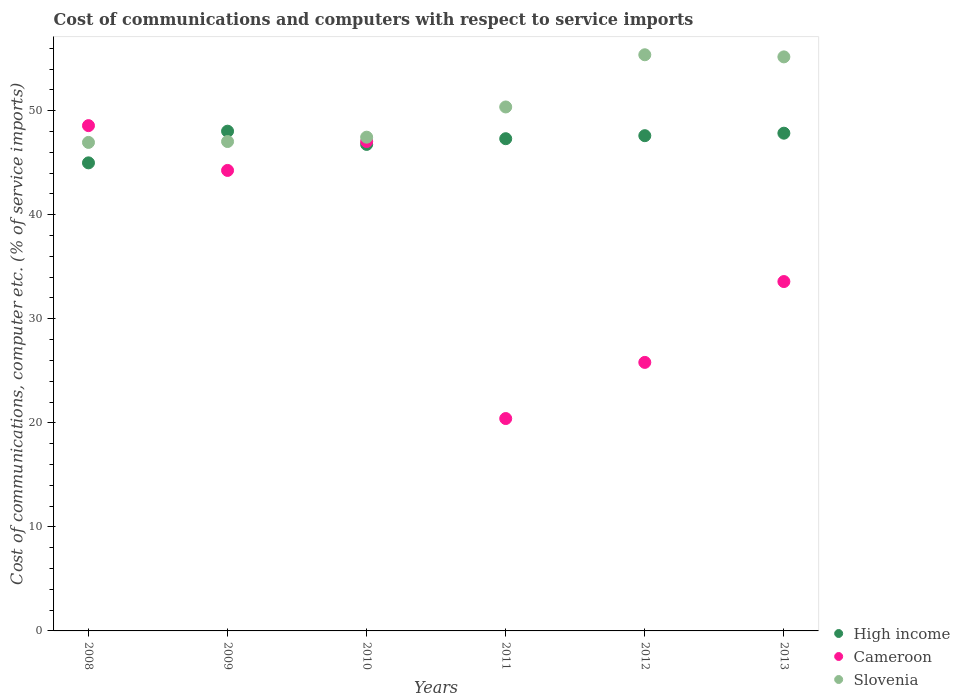What is the cost of communications and computers in Slovenia in 2009?
Make the answer very short. 47.03. Across all years, what is the maximum cost of communications and computers in Cameroon?
Ensure brevity in your answer.  48.56. Across all years, what is the minimum cost of communications and computers in Slovenia?
Provide a short and direct response. 46.95. In which year was the cost of communications and computers in High income maximum?
Offer a very short reply. 2009. What is the total cost of communications and computers in Cameroon in the graph?
Your answer should be compact. 219.64. What is the difference between the cost of communications and computers in Slovenia in 2009 and that in 2011?
Provide a short and direct response. -3.32. What is the difference between the cost of communications and computers in High income in 2008 and the cost of communications and computers in Slovenia in 2009?
Keep it short and to the point. -2.05. What is the average cost of communications and computers in Cameroon per year?
Your response must be concise. 36.61. In the year 2009, what is the difference between the cost of communications and computers in Slovenia and cost of communications and computers in High income?
Keep it short and to the point. -0.99. In how many years, is the cost of communications and computers in Slovenia greater than 16 %?
Offer a terse response. 6. What is the ratio of the cost of communications and computers in High income in 2008 to that in 2010?
Give a very brief answer. 0.96. Is the cost of communications and computers in High income in 2008 less than that in 2012?
Your response must be concise. Yes. What is the difference between the highest and the second highest cost of communications and computers in High income?
Offer a very short reply. 0.19. What is the difference between the highest and the lowest cost of communications and computers in Cameroon?
Ensure brevity in your answer.  28.15. Is it the case that in every year, the sum of the cost of communications and computers in Slovenia and cost of communications and computers in High income  is greater than the cost of communications and computers in Cameroon?
Give a very brief answer. Yes. Does the cost of communications and computers in Cameroon monotonically increase over the years?
Offer a terse response. No. Is the cost of communications and computers in High income strictly greater than the cost of communications and computers in Cameroon over the years?
Offer a terse response. No. Is the cost of communications and computers in Slovenia strictly less than the cost of communications and computers in Cameroon over the years?
Your answer should be compact. No. How many years are there in the graph?
Your answer should be compact. 6. Are the values on the major ticks of Y-axis written in scientific E-notation?
Give a very brief answer. No. Does the graph contain grids?
Provide a succinct answer. No. How many legend labels are there?
Your answer should be compact. 3. What is the title of the graph?
Provide a succinct answer. Cost of communications and computers with respect to service imports. What is the label or title of the X-axis?
Offer a terse response. Years. What is the label or title of the Y-axis?
Offer a terse response. Cost of communications, computer etc. (% of service imports). What is the Cost of communications, computer etc. (% of service imports) of High income in 2008?
Make the answer very short. 44.98. What is the Cost of communications, computer etc. (% of service imports) in Cameroon in 2008?
Ensure brevity in your answer.  48.56. What is the Cost of communications, computer etc. (% of service imports) in Slovenia in 2008?
Your response must be concise. 46.95. What is the Cost of communications, computer etc. (% of service imports) of High income in 2009?
Your answer should be compact. 48.03. What is the Cost of communications, computer etc. (% of service imports) of Cameroon in 2009?
Keep it short and to the point. 44.26. What is the Cost of communications, computer etc. (% of service imports) of Slovenia in 2009?
Your answer should be very brief. 47.03. What is the Cost of communications, computer etc. (% of service imports) of High income in 2010?
Provide a short and direct response. 46.76. What is the Cost of communications, computer etc. (% of service imports) in Cameroon in 2010?
Give a very brief answer. 47.03. What is the Cost of communications, computer etc. (% of service imports) of Slovenia in 2010?
Offer a terse response. 47.45. What is the Cost of communications, computer etc. (% of service imports) in High income in 2011?
Keep it short and to the point. 47.3. What is the Cost of communications, computer etc. (% of service imports) in Cameroon in 2011?
Provide a short and direct response. 20.41. What is the Cost of communications, computer etc. (% of service imports) of Slovenia in 2011?
Your answer should be compact. 50.35. What is the Cost of communications, computer etc. (% of service imports) of High income in 2012?
Provide a succinct answer. 47.59. What is the Cost of communications, computer etc. (% of service imports) in Cameroon in 2012?
Ensure brevity in your answer.  25.81. What is the Cost of communications, computer etc. (% of service imports) of Slovenia in 2012?
Provide a short and direct response. 55.37. What is the Cost of communications, computer etc. (% of service imports) of High income in 2013?
Your answer should be compact. 47.83. What is the Cost of communications, computer etc. (% of service imports) of Cameroon in 2013?
Ensure brevity in your answer.  33.58. What is the Cost of communications, computer etc. (% of service imports) of Slovenia in 2013?
Your answer should be compact. 55.17. Across all years, what is the maximum Cost of communications, computer etc. (% of service imports) in High income?
Ensure brevity in your answer.  48.03. Across all years, what is the maximum Cost of communications, computer etc. (% of service imports) of Cameroon?
Provide a succinct answer. 48.56. Across all years, what is the maximum Cost of communications, computer etc. (% of service imports) in Slovenia?
Keep it short and to the point. 55.37. Across all years, what is the minimum Cost of communications, computer etc. (% of service imports) in High income?
Provide a short and direct response. 44.98. Across all years, what is the minimum Cost of communications, computer etc. (% of service imports) in Cameroon?
Provide a short and direct response. 20.41. Across all years, what is the minimum Cost of communications, computer etc. (% of service imports) in Slovenia?
Provide a succinct answer. 46.95. What is the total Cost of communications, computer etc. (% of service imports) in High income in the graph?
Provide a short and direct response. 282.5. What is the total Cost of communications, computer etc. (% of service imports) of Cameroon in the graph?
Give a very brief answer. 219.64. What is the total Cost of communications, computer etc. (% of service imports) of Slovenia in the graph?
Provide a short and direct response. 302.32. What is the difference between the Cost of communications, computer etc. (% of service imports) in High income in 2008 and that in 2009?
Provide a succinct answer. -3.04. What is the difference between the Cost of communications, computer etc. (% of service imports) in Cameroon in 2008 and that in 2009?
Offer a very short reply. 4.3. What is the difference between the Cost of communications, computer etc. (% of service imports) in Slovenia in 2008 and that in 2009?
Ensure brevity in your answer.  -0.08. What is the difference between the Cost of communications, computer etc. (% of service imports) in High income in 2008 and that in 2010?
Provide a succinct answer. -1.77. What is the difference between the Cost of communications, computer etc. (% of service imports) of Cameroon in 2008 and that in 2010?
Your response must be concise. 1.53. What is the difference between the Cost of communications, computer etc. (% of service imports) of Slovenia in 2008 and that in 2010?
Ensure brevity in your answer.  -0.5. What is the difference between the Cost of communications, computer etc. (% of service imports) in High income in 2008 and that in 2011?
Provide a succinct answer. -2.32. What is the difference between the Cost of communications, computer etc. (% of service imports) of Cameroon in 2008 and that in 2011?
Offer a terse response. 28.15. What is the difference between the Cost of communications, computer etc. (% of service imports) in Slovenia in 2008 and that in 2011?
Offer a terse response. -3.41. What is the difference between the Cost of communications, computer etc. (% of service imports) in High income in 2008 and that in 2012?
Give a very brief answer. -2.61. What is the difference between the Cost of communications, computer etc. (% of service imports) in Cameroon in 2008 and that in 2012?
Make the answer very short. 22.75. What is the difference between the Cost of communications, computer etc. (% of service imports) of Slovenia in 2008 and that in 2012?
Your answer should be very brief. -8.42. What is the difference between the Cost of communications, computer etc. (% of service imports) in High income in 2008 and that in 2013?
Your response must be concise. -2.85. What is the difference between the Cost of communications, computer etc. (% of service imports) of Cameroon in 2008 and that in 2013?
Ensure brevity in your answer.  14.98. What is the difference between the Cost of communications, computer etc. (% of service imports) of Slovenia in 2008 and that in 2013?
Your answer should be very brief. -8.22. What is the difference between the Cost of communications, computer etc. (% of service imports) of High income in 2009 and that in 2010?
Your answer should be compact. 1.27. What is the difference between the Cost of communications, computer etc. (% of service imports) in Cameroon in 2009 and that in 2010?
Your answer should be very brief. -2.78. What is the difference between the Cost of communications, computer etc. (% of service imports) in Slovenia in 2009 and that in 2010?
Make the answer very short. -0.42. What is the difference between the Cost of communications, computer etc. (% of service imports) of High income in 2009 and that in 2011?
Offer a terse response. 0.72. What is the difference between the Cost of communications, computer etc. (% of service imports) of Cameroon in 2009 and that in 2011?
Offer a terse response. 23.85. What is the difference between the Cost of communications, computer etc. (% of service imports) in Slovenia in 2009 and that in 2011?
Give a very brief answer. -3.32. What is the difference between the Cost of communications, computer etc. (% of service imports) in High income in 2009 and that in 2012?
Keep it short and to the point. 0.43. What is the difference between the Cost of communications, computer etc. (% of service imports) of Cameroon in 2009 and that in 2012?
Your response must be concise. 18.45. What is the difference between the Cost of communications, computer etc. (% of service imports) in Slovenia in 2009 and that in 2012?
Your answer should be compact. -8.34. What is the difference between the Cost of communications, computer etc. (% of service imports) in High income in 2009 and that in 2013?
Keep it short and to the point. 0.19. What is the difference between the Cost of communications, computer etc. (% of service imports) of Cameroon in 2009 and that in 2013?
Your answer should be compact. 10.68. What is the difference between the Cost of communications, computer etc. (% of service imports) in Slovenia in 2009 and that in 2013?
Your answer should be compact. -8.14. What is the difference between the Cost of communications, computer etc. (% of service imports) in High income in 2010 and that in 2011?
Your answer should be compact. -0.55. What is the difference between the Cost of communications, computer etc. (% of service imports) of Cameroon in 2010 and that in 2011?
Offer a very short reply. 26.62. What is the difference between the Cost of communications, computer etc. (% of service imports) in Slovenia in 2010 and that in 2011?
Offer a very short reply. -2.9. What is the difference between the Cost of communications, computer etc. (% of service imports) of High income in 2010 and that in 2012?
Provide a short and direct response. -0.84. What is the difference between the Cost of communications, computer etc. (% of service imports) in Cameroon in 2010 and that in 2012?
Offer a very short reply. 21.23. What is the difference between the Cost of communications, computer etc. (% of service imports) of Slovenia in 2010 and that in 2012?
Offer a very short reply. -7.92. What is the difference between the Cost of communications, computer etc. (% of service imports) of High income in 2010 and that in 2013?
Give a very brief answer. -1.08. What is the difference between the Cost of communications, computer etc. (% of service imports) of Cameroon in 2010 and that in 2013?
Offer a terse response. 13.46. What is the difference between the Cost of communications, computer etc. (% of service imports) in Slovenia in 2010 and that in 2013?
Offer a terse response. -7.72. What is the difference between the Cost of communications, computer etc. (% of service imports) of High income in 2011 and that in 2012?
Provide a succinct answer. -0.29. What is the difference between the Cost of communications, computer etc. (% of service imports) in Cameroon in 2011 and that in 2012?
Keep it short and to the point. -5.4. What is the difference between the Cost of communications, computer etc. (% of service imports) of Slovenia in 2011 and that in 2012?
Keep it short and to the point. -5.02. What is the difference between the Cost of communications, computer etc. (% of service imports) of High income in 2011 and that in 2013?
Give a very brief answer. -0.53. What is the difference between the Cost of communications, computer etc. (% of service imports) of Cameroon in 2011 and that in 2013?
Your response must be concise. -13.17. What is the difference between the Cost of communications, computer etc. (% of service imports) in Slovenia in 2011 and that in 2013?
Your answer should be compact. -4.81. What is the difference between the Cost of communications, computer etc. (% of service imports) of High income in 2012 and that in 2013?
Make the answer very short. -0.24. What is the difference between the Cost of communications, computer etc. (% of service imports) in Cameroon in 2012 and that in 2013?
Provide a short and direct response. -7.77. What is the difference between the Cost of communications, computer etc. (% of service imports) in Slovenia in 2012 and that in 2013?
Provide a short and direct response. 0.2. What is the difference between the Cost of communications, computer etc. (% of service imports) in High income in 2008 and the Cost of communications, computer etc. (% of service imports) in Cameroon in 2009?
Offer a very short reply. 0.73. What is the difference between the Cost of communications, computer etc. (% of service imports) in High income in 2008 and the Cost of communications, computer etc. (% of service imports) in Slovenia in 2009?
Your response must be concise. -2.05. What is the difference between the Cost of communications, computer etc. (% of service imports) of Cameroon in 2008 and the Cost of communications, computer etc. (% of service imports) of Slovenia in 2009?
Make the answer very short. 1.53. What is the difference between the Cost of communications, computer etc. (% of service imports) of High income in 2008 and the Cost of communications, computer etc. (% of service imports) of Cameroon in 2010?
Provide a short and direct response. -2.05. What is the difference between the Cost of communications, computer etc. (% of service imports) in High income in 2008 and the Cost of communications, computer etc. (% of service imports) in Slovenia in 2010?
Keep it short and to the point. -2.47. What is the difference between the Cost of communications, computer etc. (% of service imports) in Cameroon in 2008 and the Cost of communications, computer etc. (% of service imports) in Slovenia in 2010?
Your answer should be very brief. 1.11. What is the difference between the Cost of communications, computer etc. (% of service imports) of High income in 2008 and the Cost of communications, computer etc. (% of service imports) of Cameroon in 2011?
Keep it short and to the point. 24.57. What is the difference between the Cost of communications, computer etc. (% of service imports) in High income in 2008 and the Cost of communications, computer etc. (% of service imports) in Slovenia in 2011?
Provide a succinct answer. -5.37. What is the difference between the Cost of communications, computer etc. (% of service imports) in Cameroon in 2008 and the Cost of communications, computer etc. (% of service imports) in Slovenia in 2011?
Keep it short and to the point. -1.79. What is the difference between the Cost of communications, computer etc. (% of service imports) in High income in 2008 and the Cost of communications, computer etc. (% of service imports) in Cameroon in 2012?
Offer a very short reply. 19.18. What is the difference between the Cost of communications, computer etc. (% of service imports) in High income in 2008 and the Cost of communications, computer etc. (% of service imports) in Slovenia in 2012?
Keep it short and to the point. -10.39. What is the difference between the Cost of communications, computer etc. (% of service imports) of Cameroon in 2008 and the Cost of communications, computer etc. (% of service imports) of Slovenia in 2012?
Your answer should be compact. -6.81. What is the difference between the Cost of communications, computer etc. (% of service imports) of High income in 2008 and the Cost of communications, computer etc. (% of service imports) of Cameroon in 2013?
Offer a very short reply. 11.41. What is the difference between the Cost of communications, computer etc. (% of service imports) of High income in 2008 and the Cost of communications, computer etc. (% of service imports) of Slovenia in 2013?
Give a very brief answer. -10.19. What is the difference between the Cost of communications, computer etc. (% of service imports) of Cameroon in 2008 and the Cost of communications, computer etc. (% of service imports) of Slovenia in 2013?
Offer a very short reply. -6.61. What is the difference between the Cost of communications, computer etc. (% of service imports) in High income in 2009 and the Cost of communications, computer etc. (% of service imports) in Cameroon in 2010?
Your answer should be compact. 0.99. What is the difference between the Cost of communications, computer etc. (% of service imports) in High income in 2009 and the Cost of communications, computer etc. (% of service imports) in Slovenia in 2010?
Offer a very short reply. 0.58. What is the difference between the Cost of communications, computer etc. (% of service imports) in Cameroon in 2009 and the Cost of communications, computer etc. (% of service imports) in Slovenia in 2010?
Offer a terse response. -3.2. What is the difference between the Cost of communications, computer etc. (% of service imports) in High income in 2009 and the Cost of communications, computer etc. (% of service imports) in Cameroon in 2011?
Your response must be concise. 27.62. What is the difference between the Cost of communications, computer etc. (% of service imports) in High income in 2009 and the Cost of communications, computer etc. (% of service imports) in Slovenia in 2011?
Give a very brief answer. -2.33. What is the difference between the Cost of communications, computer etc. (% of service imports) in Cameroon in 2009 and the Cost of communications, computer etc. (% of service imports) in Slovenia in 2011?
Offer a very short reply. -6.1. What is the difference between the Cost of communications, computer etc. (% of service imports) of High income in 2009 and the Cost of communications, computer etc. (% of service imports) of Cameroon in 2012?
Your answer should be very brief. 22.22. What is the difference between the Cost of communications, computer etc. (% of service imports) in High income in 2009 and the Cost of communications, computer etc. (% of service imports) in Slovenia in 2012?
Keep it short and to the point. -7.34. What is the difference between the Cost of communications, computer etc. (% of service imports) of Cameroon in 2009 and the Cost of communications, computer etc. (% of service imports) of Slovenia in 2012?
Offer a very short reply. -11.12. What is the difference between the Cost of communications, computer etc. (% of service imports) in High income in 2009 and the Cost of communications, computer etc. (% of service imports) in Cameroon in 2013?
Offer a terse response. 14.45. What is the difference between the Cost of communications, computer etc. (% of service imports) of High income in 2009 and the Cost of communications, computer etc. (% of service imports) of Slovenia in 2013?
Offer a terse response. -7.14. What is the difference between the Cost of communications, computer etc. (% of service imports) in Cameroon in 2009 and the Cost of communications, computer etc. (% of service imports) in Slovenia in 2013?
Make the answer very short. -10.91. What is the difference between the Cost of communications, computer etc. (% of service imports) of High income in 2010 and the Cost of communications, computer etc. (% of service imports) of Cameroon in 2011?
Your response must be concise. 26.35. What is the difference between the Cost of communications, computer etc. (% of service imports) in High income in 2010 and the Cost of communications, computer etc. (% of service imports) in Slovenia in 2011?
Make the answer very short. -3.6. What is the difference between the Cost of communications, computer etc. (% of service imports) in Cameroon in 2010 and the Cost of communications, computer etc. (% of service imports) in Slovenia in 2011?
Keep it short and to the point. -3.32. What is the difference between the Cost of communications, computer etc. (% of service imports) of High income in 2010 and the Cost of communications, computer etc. (% of service imports) of Cameroon in 2012?
Offer a terse response. 20.95. What is the difference between the Cost of communications, computer etc. (% of service imports) in High income in 2010 and the Cost of communications, computer etc. (% of service imports) in Slovenia in 2012?
Offer a very short reply. -8.61. What is the difference between the Cost of communications, computer etc. (% of service imports) of Cameroon in 2010 and the Cost of communications, computer etc. (% of service imports) of Slovenia in 2012?
Keep it short and to the point. -8.34. What is the difference between the Cost of communications, computer etc. (% of service imports) in High income in 2010 and the Cost of communications, computer etc. (% of service imports) in Cameroon in 2013?
Offer a terse response. 13.18. What is the difference between the Cost of communications, computer etc. (% of service imports) of High income in 2010 and the Cost of communications, computer etc. (% of service imports) of Slovenia in 2013?
Offer a terse response. -8.41. What is the difference between the Cost of communications, computer etc. (% of service imports) in Cameroon in 2010 and the Cost of communications, computer etc. (% of service imports) in Slovenia in 2013?
Keep it short and to the point. -8.14. What is the difference between the Cost of communications, computer etc. (% of service imports) in High income in 2011 and the Cost of communications, computer etc. (% of service imports) in Cameroon in 2012?
Offer a very short reply. 21.5. What is the difference between the Cost of communications, computer etc. (% of service imports) of High income in 2011 and the Cost of communications, computer etc. (% of service imports) of Slovenia in 2012?
Your answer should be compact. -8.07. What is the difference between the Cost of communications, computer etc. (% of service imports) of Cameroon in 2011 and the Cost of communications, computer etc. (% of service imports) of Slovenia in 2012?
Give a very brief answer. -34.96. What is the difference between the Cost of communications, computer etc. (% of service imports) of High income in 2011 and the Cost of communications, computer etc. (% of service imports) of Cameroon in 2013?
Give a very brief answer. 13.73. What is the difference between the Cost of communications, computer etc. (% of service imports) in High income in 2011 and the Cost of communications, computer etc. (% of service imports) in Slovenia in 2013?
Your answer should be very brief. -7.86. What is the difference between the Cost of communications, computer etc. (% of service imports) of Cameroon in 2011 and the Cost of communications, computer etc. (% of service imports) of Slovenia in 2013?
Keep it short and to the point. -34.76. What is the difference between the Cost of communications, computer etc. (% of service imports) of High income in 2012 and the Cost of communications, computer etc. (% of service imports) of Cameroon in 2013?
Provide a succinct answer. 14.02. What is the difference between the Cost of communications, computer etc. (% of service imports) in High income in 2012 and the Cost of communications, computer etc. (% of service imports) in Slovenia in 2013?
Keep it short and to the point. -7.57. What is the difference between the Cost of communications, computer etc. (% of service imports) of Cameroon in 2012 and the Cost of communications, computer etc. (% of service imports) of Slovenia in 2013?
Provide a succinct answer. -29.36. What is the average Cost of communications, computer etc. (% of service imports) in High income per year?
Make the answer very short. 47.08. What is the average Cost of communications, computer etc. (% of service imports) in Cameroon per year?
Ensure brevity in your answer.  36.61. What is the average Cost of communications, computer etc. (% of service imports) in Slovenia per year?
Your answer should be very brief. 50.39. In the year 2008, what is the difference between the Cost of communications, computer etc. (% of service imports) in High income and Cost of communications, computer etc. (% of service imports) in Cameroon?
Your response must be concise. -3.58. In the year 2008, what is the difference between the Cost of communications, computer etc. (% of service imports) in High income and Cost of communications, computer etc. (% of service imports) in Slovenia?
Provide a short and direct response. -1.96. In the year 2008, what is the difference between the Cost of communications, computer etc. (% of service imports) of Cameroon and Cost of communications, computer etc. (% of service imports) of Slovenia?
Your response must be concise. 1.61. In the year 2009, what is the difference between the Cost of communications, computer etc. (% of service imports) of High income and Cost of communications, computer etc. (% of service imports) of Cameroon?
Ensure brevity in your answer.  3.77. In the year 2009, what is the difference between the Cost of communications, computer etc. (% of service imports) of High income and Cost of communications, computer etc. (% of service imports) of Slovenia?
Provide a succinct answer. 0.99. In the year 2009, what is the difference between the Cost of communications, computer etc. (% of service imports) of Cameroon and Cost of communications, computer etc. (% of service imports) of Slovenia?
Offer a terse response. -2.78. In the year 2010, what is the difference between the Cost of communications, computer etc. (% of service imports) of High income and Cost of communications, computer etc. (% of service imports) of Cameroon?
Offer a terse response. -0.28. In the year 2010, what is the difference between the Cost of communications, computer etc. (% of service imports) of High income and Cost of communications, computer etc. (% of service imports) of Slovenia?
Offer a terse response. -0.69. In the year 2010, what is the difference between the Cost of communications, computer etc. (% of service imports) in Cameroon and Cost of communications, computer etc. (% of service imports) in Slovenia?
Give a very brief answer. -0.42. In the year 2011, what is the difference between the Cost of communications, computer etc. (% of service imports) in High income and Cost of communications, computer etc. (% of service imports) in Cameroon?
Your answer should be compact. 26.89. In the year 2011, what is the difference between the Cost of communications, computer etc. (% of service imports) in High income and Cost of communications, computer etc. (% of service imports) in Slovenia?
Provide a succinct answer. -3.05. In the year 2011, what is the difference between the Cost of communications, computer etc. (% of service imports) in Cameroon and Cost of communications, computer etc. (% of service imports) in Slovenia?
Provide a short and direct response. -29.94. In the year 2012, what is the difference between the Cost of communications, computer etc. (% of service imports) of High income and Cost of communications, computer etc. (% of service imports) of Cameroon?
Provide a succinct answer. 21.79. In the year 2012, what is the difference between the Cost of communications, computer etc. (% of service imports) in High income and Cost of communications, computer etc. (% of service imports) in Slovenia?
Provide a succinct answer. -7.78. In the year 2012, what is the difference between the Cost of communications, computer etc. (% of service imports) of Cameroon and Cost of communications, computer etc. (% of service imports) of Slovenia?
Make the answer very short. -29.56. In the year 2013, what is the difference between the Cost of communications, computer etc. (% of service imports) of High income and Cost of communications, computer etc. (% of service imports) of Cameroon?
Your answer should be very brief. 14.26. In the year 2013, what is the difference between the Cost of communications, computer etc. (% of service imports) of High income and Cost of communications, computer etc. (% of service imports) of Slovenia?
Provide a short and direct response. -7.33. In the year 2013, what is the difference between the Cost of communications, computer etc. (% of service imports) of Cameroon and Cost of communications, computer etc. (% of service imports) of Slovenia?
Your response must be concise. -21.59. What is the ratio of the Cost of communications, computer etc. (% of service imports) of High income in 2008 to that in 2009?
Offer a terse response. 0.94. What is the ratio of the Cost of communications, computer etc. (% of service imports) of Cameroon in 2008 to that in 2009?
Your response must be concise. 1.1. What is the ratio of the Cost of communications, computer etc. (% of service imports) in High income in 2008 to that in 2010?
Offer a very short reply. 0.96. What is the ratio of the Cost of communications, computer etc. (% of service imports) in Cameroon in 2008 to that in 2010?
Offer a very short reply. 1.03. What is the ratio of the Cost of communications, computer etc. (% of service imports) in High income in 2008 to that in 2011?
Make the answer very short. 0.95. What is the ratio of the Cost of communications, computer etc. (% of service imports) of Cameroon in 2008 to that in 2011?
Your response must be concise. 2.38. What is the ratio of the Cost of communications, computer etc. (% of service imports) of Slovenia in 2008 to that in 2011?
Keep it short and to the point. 0.93. What is the ratio of the Cost of communications, computer etc. (% of service imports) of High income in 2008 to that in 2012?
Your answer should be compact. 0.95. What is the ratio of the Cost of communications, computer etc. (% of service imports) of Cameroon in 2008 to that in 2012?
Keep it short and to the point. 1.88. What is the ratio of the Cost of communications, computer etc. (% of service imports) in Slovenia in 2008 to that in 2012?
Provide a succinct answer. 0.85. What is the ratio of the Cost of communications, computer etc. (% of service imports) in High income in 2008 to that in 2013?
Give a very brief answer. 0.94. What is the ratio of the Cost of communications, computer etc. (% of service imports) in Cameroon in 2008 to that in 2013?
Your answer should be compact. 1.45. What is the ratio of the Cost of communications, computer etc. (% of service imports) in Slovenia in 2008 to that in 2013?
Keep it short and to the point. 0.85. What is the ratio of the Cost of communications, computer etc. (% of service imports) in High income in 2009 to that in 2010?
Your response must be concise. 1.03. What is the ratio of the Cost of communications, computer etc. (% of service imports) of Cameroon in 2009 to that in 2010?
Offer a terse response. 0.94. What is the ratio of the Cost of communications, computer etc. (% of service imports) of High income in 2009 to that in 2011?
Your answer should be very brief. 1.02. What is the ratio of the Cost of communications, computer etc. (% of service imports) in Cameroon in 2009 to that in 2011?
Offer a terse response. 2.17. What is the ratio of the Cost of communications, computer etc. (% of service imports) in Slovenia in 2009 to that in 2011?
Your answer should be compact. 0.93. What is the ratio of the Cost of communications, computer etc. (% of service imports) of High income in 2009 to that in 2012?
Ensure brevity in your answer.  1.01. What is the ratio of the Cost of communications, computer etc. (% of service imports) of Cameroon in 2009 to that in 2012?
Ensure brevity in your answer.  1.71. What is the ratio of the Cost of communications, computer etc. (% of service imports) in Slovenia in 2009 to that in 2012?
Keep it short and to the point. 0.85. What is the ratio of the Cost of communications, computer etc. (% of service imports) of High income in 2009 to that in 2013?
Provide a succinct answer. 1. What is the ratio of the Cost of communications, computer etc. (% of service imports) of Cameroon in 2009 to that in 2013?
Provide a succinct answer. 1.32. What is the ratio of the Cost of communications, computer etc. (% of service imports) of Slovenia in 2009 to that in 2013?
Give a very brief answer. 0.85. What is the ratio of the Cost of communications, computer etc. (% of service imports) of High income in 2010 to that in 2011?
Provide a succinct answer. 0.99. What is the ratio of the Cost of communications, computer etc. (% of service imports) in Cameroon in 2010 to that in 2011?
Offer a terse response. 2.3. What is the ratio of the Cost of communications, computer etc. (% of service imports) in Slovenia in 2010 to that in 2011?
Give a very brief answer. 0.94. What is the ratio of the Cost of communications, computer etc. (% of service imports) of High income in 2010 to that in 2012?
Provide a succinct answer. 0.98. What is the ratio of the Cost of communications, computer etc. (% of service imports) of Cameroon in 2010 to that in 2012?
Provide a succinct answer. 1.82. What is the ratio of the Cost of communications, computer etc. (% of service imports) of Slovenia in 2010 to that in 2012?
Your answer should be very brief. 0.86. What is the ratio of the Cost of communications, computer etc. (% of service imports) in High income in 2010 to that in 2013?
Provide a succinct answer. 0.98. What is the ratio of the Cost of communications, computer etc. (% of service imports) of Cameroon in 2010 to that in 2013?
Ensure brevity in your answer.  1.4. What is the ratio of the Cost of communications, computer etc. (% of service imports) in Slovenia in 2010 to that in 2013?
Give a very brief answer. 0.86. What is the ratio of the Cost of communications, computer etc. (% of service imports) of High income in 2011 to that in 2012?
Your answer should be compact. 0.99. What is the ratio of the Cost of communications, computer etc. (% of service imports) of Cameroon in 2011 to that in 2012?
Your response must be concise. 0.79. What is the ratio of the Cost of communications, computer etc. (% of service imports) of Slovenia in 2011 to that in 2012?
Offer a terse response. 0.91. What is the ratio of the Cost of communications, computer etc. (% of service imports) in High income in 2011 to that in 2013?
Give a very brief answer. 0.99. What is the ratio of the Cost of communications, computer etc. (% of service imports) of Cameroon in 2011 to that in 2013?
Your answer should be very brief. 0.61. What is the ratio of the Cost of communications, computer etc. (% of service imports) in Slovenia in 2011 to that in 2013?
Your answer should be very brief. 0.91. What is the ratio of the Cost of communications, computer etc. (% of service imports) of Cameroon in 2012 to that in 2013?
Make the answer very short. 0.77. What is the ratio of the Cost of communications, computer etc. (% of service imports) in Slovenia in 2012 to that in 2013?
Offer a very short reply. 1. What is the difference between the highest and the second highest Cost of communications, computer etc. (% of service imports) of High income?
Your answer should be compact. 0.19. What is the difference between the highest and the second highest Cost of communications, computer etc. (% of service imports) in Cameroon?
Offer a very short reply. 1.53. What is the difference between the highest and the second highest Cost of communications, computer etc. (% of service imports) of Slovenia?
Offer a very short reply. 0.2. What is the difference between the highest and the lowest Cost of communications, computer etc. (% of service imports) in High income?
Give a very brief answer. 3.04. What is the difference between the highest and the lowest Cost of communications, computer etc. (% of service imports) of Cameroon?
Offer a terse response. 28.15. What is the difference between the highest and the lowest Cost of communications, computer etc. (% of service imports) of Slovenia?
Your answer should be very brief. 8.42. 